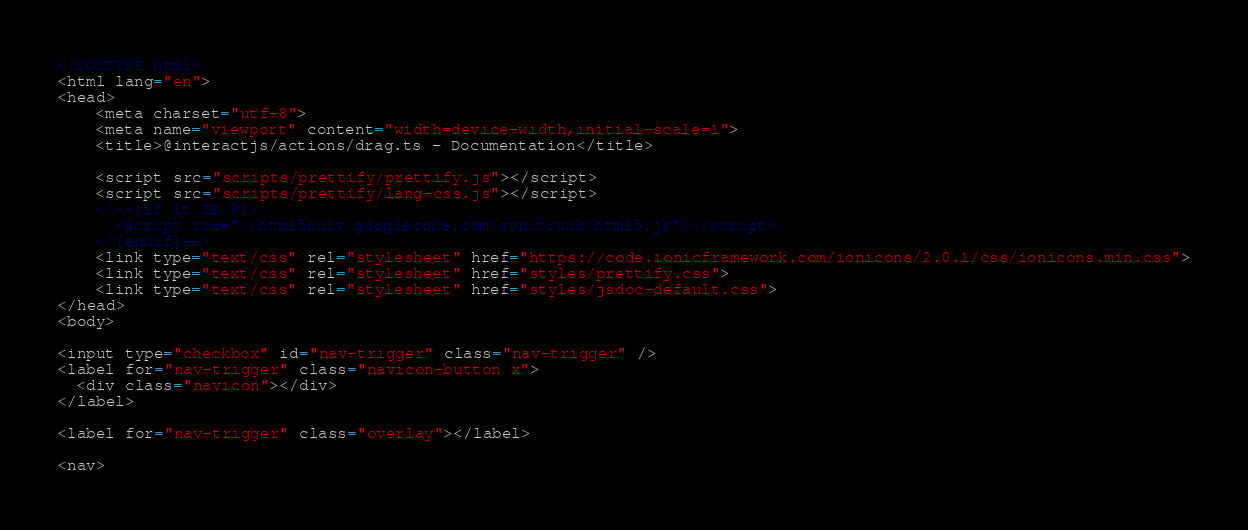<code> <loc_0><loc_0><loc_500><loc_500><_HTML_><!DOCTYPE html>
<html lang="en">
<head>
    <meta charset="utf-8">
    <meta name="viewport" content="width=device-width,initial-scale=1">
    <title>@interactjs/actions/drag.ts - Documentation</title>

    <script src="scripts/prettify/prettify.js"></script>
    <script src="scripts/prettify/lang-css.js"></script>
    <!--[if lt IE 9]>
      <script src="//html5shiv.googlecode.com/svn/trunk/html5.js"></script>
    <![endif]-->
    <link type="text/css" rel="stylesheet" href="https://code.ionicframework.com/ionicons/2.0.1/css/ionicons.min.css">
    <link type="text/css" rel="stylesheet" href="styles/prettify.css">
    <link type="text/css" rel="stylesheet" href="styles/jsdoc-default.css">
</head>
<body>

<input type="checkbox" id="nav-trigger" class="nav-trigger" />
<label for="nav-trigger" class="navicon-button x">
  <div class="navicon"></div>
</label>

<label for="nav-trigger" class="overlay"></label>

<nav></code> 